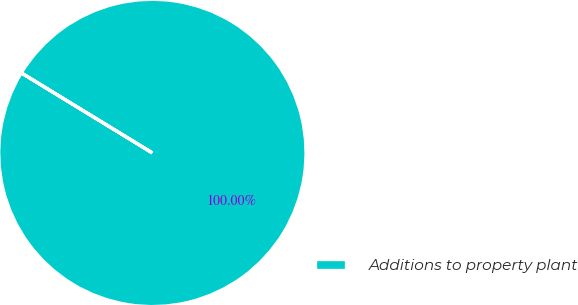Convert chart. <chart><loc_0><loc_0><loc_500><loc_500><pie_chart><fcel>Additions to property plant<nl><fcel>100.0%<nl></chart> 